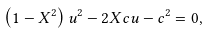Convert formula to latex. <formula><loc_0><loc_0><loc_500><loc_500>\left ( 1 - X ^ { 2 } \right ) u ^ { 2 } - 2 X c u - c ^ { 2 } = 0 ,</formula> 